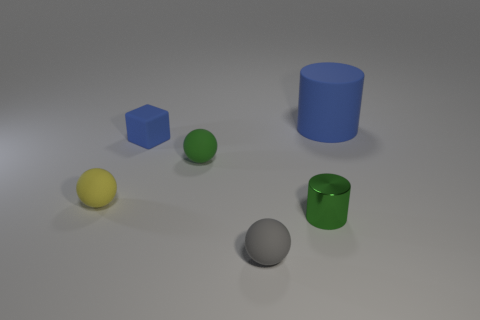Add 2 large cylinders. How many objects exist? 8 Subtract all blocks. How many objects are left? 5 Subtract 1 blue cylinders. How many objects are left? 5 Subtract all gray things. Subtract all blue objects. How many objects are left? 3 Add 3 small gray rubber spheres. How many small gray rubber spheres are left? 4 Add 4 big yellow matte cubes. How many big yellow matte cubes exist? 4 